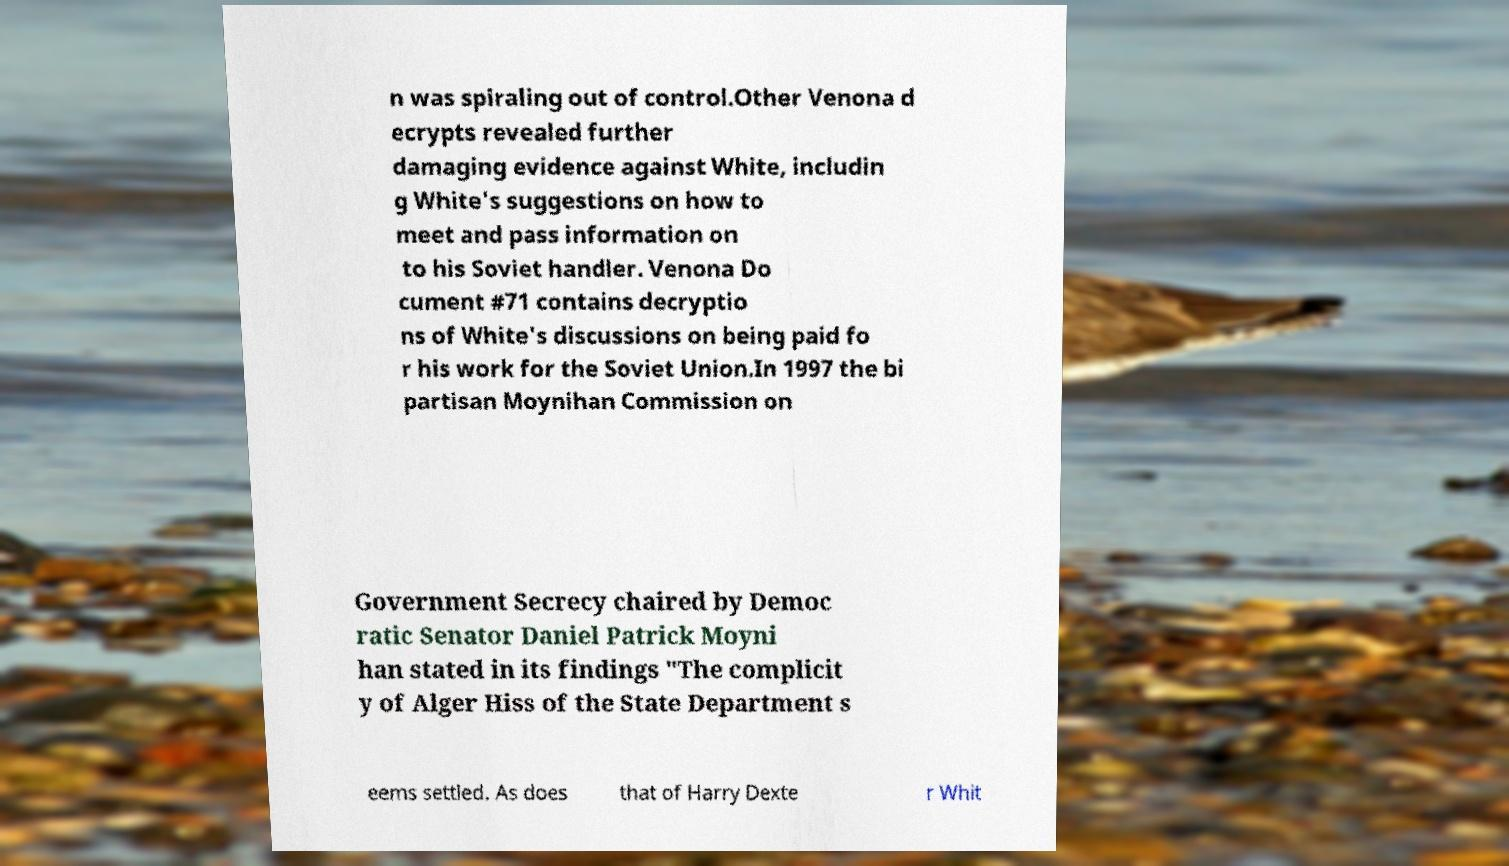What messages or text are displayed in this image? I need them in a readable, typed format. n was spiraling out of control.Other Venona d ecrypts revealed further damaging evidence against White, includin g White's suggestions on how to meet and pass information on to his Soviet handler. Venona Do cument #71 contains decryptio ns of White's discussions on being paid fo r his work for the Soviet Union.In 1997 the bi partisan Moynihan Commission on Government Secrecy chaired by Democ ratic Senator Daniel Patrick Moyni han stated in its findings "The complicit y of Alger Hiss of the State Department s eems settled. As does that of Harry Dexte r Whit 